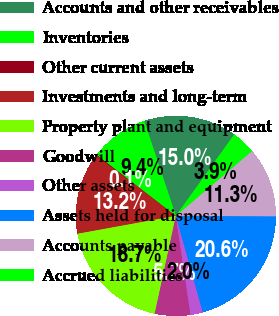<chart> <loc_0><loc_0><loc_500><loc_500><pie_chart><fcel>Accounts and other receivables<fcel>Inventories<fcel>Other current assets<fcel>Investments and long-term<fcel>Property plant and equipment<fcel>Goodwill<fcel>Other assets<fcel>Assets held for disposal<fcel>Accounts payable<fcel>Accrued liabilities<nl><fcel>15.02%<fcel>9.44%<fcel>0.14%<fcel>13.16%<fcel>18.74%<fcel>5.72%<fcel>2.0%<fcel>20.6%<fcel>11.3%<fcel>3.86%<nl></chart> 